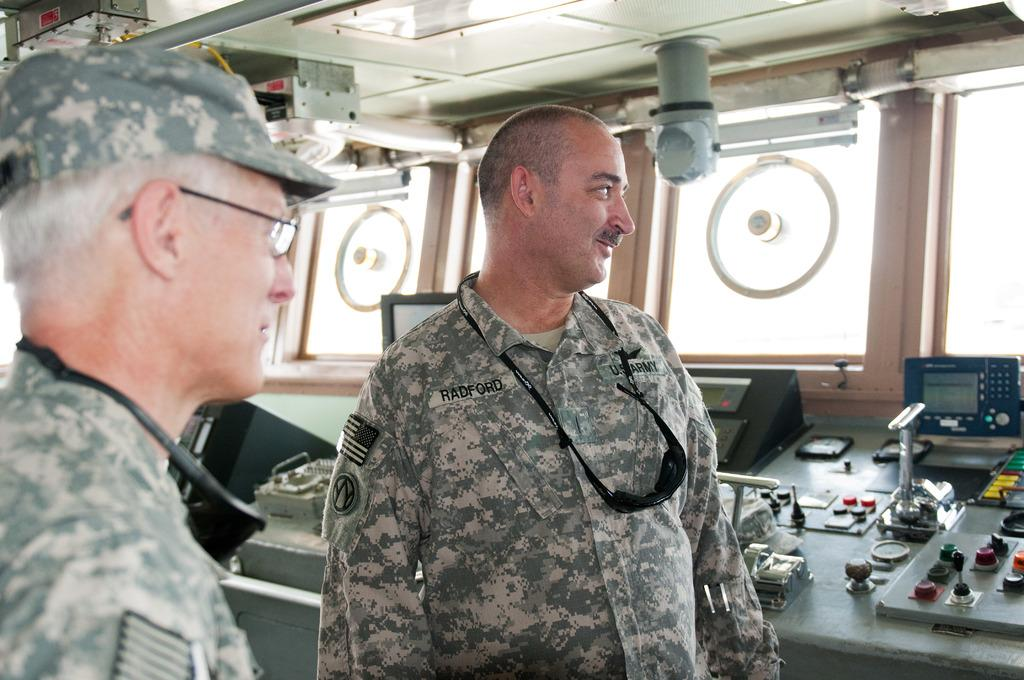How many army people are in the image? There are two army people in the image. What else can be seen in the image besides the army people? There is machinery on a table in the image. What type of place is depicted in the image during a rainstorm? There is no indication of a specific place or rainstorm in the image; it features two army people and machinery on a table. 